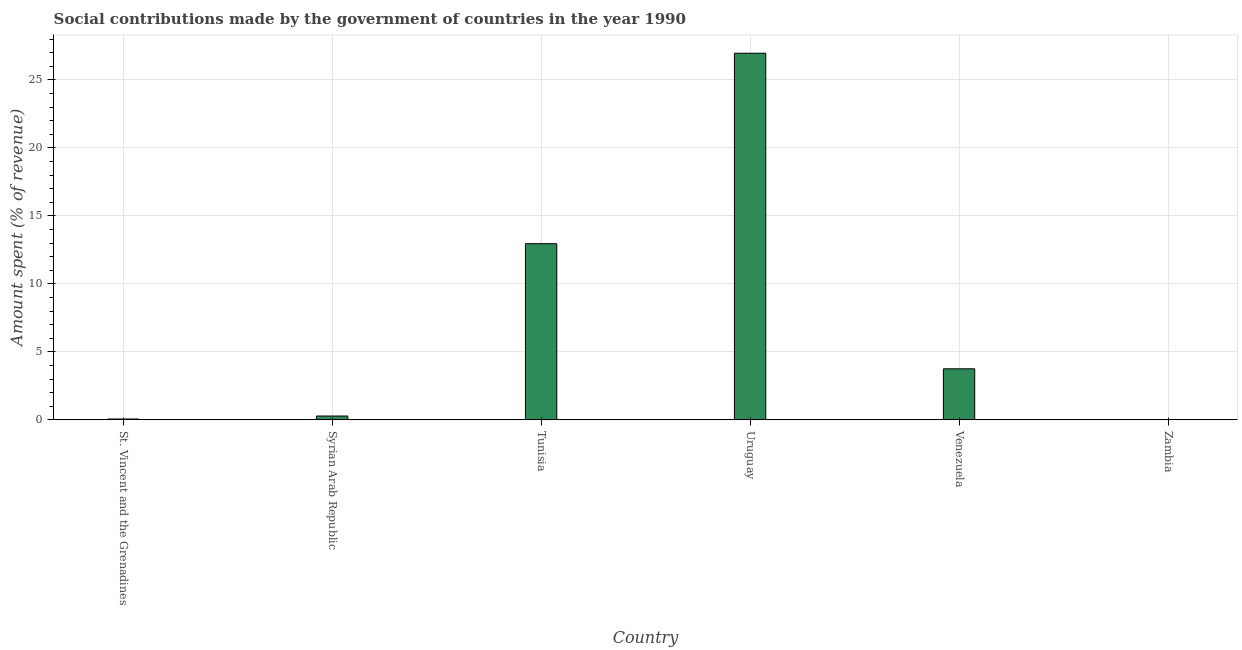What is the title of the graph?
Give a very brief answer. Social contributions made by the government of countries in the year 1990. What is the label or title of the Y-axis?
Your response must be concise. Amount spent (% of revenue). What is the amount spent in making social contributions in Syrian Arab Republic?
Give a very brief answer. 0.28. Across all countries, what is the maximum amount spent in making social contributions?
Give a very brief answer. 26.96. Across all countries, what is the minimum amount spent in making social contributions?
Give a very brief answer. 0. In which country was the amount spent in making social contributions maximum?
Your response must be concise. Uruguay. In which country was the amount spent in making social contributions minimum?
Provide a succinct answer. Zambia. What is the sum of the amount spent in making social contributions?
Offer a very short reply. 44. What is the difference between the amount spent in making social contributions in Tunisia and Venezuela?
Give a very brief answer. 9.2. What is the average amount spent in making social contributions per country?
Your response must be concise. 7.33. What is the median amount spent in making social contributions?
Provide a short and direct response. 2.01. In how many countries, is the amount spent in making social contributions greater than 20 %?
Give a very brief answer. 1. What is the ratio of the amount spent in making social contributions in Tunisia to that in Venezuela?
Your response must be concise. 3.45. What is the difference between the highest and the second highest amount spent in making social contributions?
Your answer should be very brief. 14.01. What is the difference between the highest and the lowest amount spent in making social contributions?
Offer a terse response. 26.95. In how many countries, is the amount spent in making social contributions greater than the average amount spent in making social contributions taken over all countries?
Ensure brevity in your answer.  2. What is the Amount spent (% of revenue) in St. Vincent and the Grenadines?
Make the answer very short. 0.06. What is the Amount spent (% of revenue) in Syrian Arab Republic?
Give a very brief answer. 0.28. What is the Amount spent (% of revenue) of Tunisia?
Your response must be concise. 12.95. What is the Amount spent (% of revenue) of Uruguay?
Give a very brief answer. 26.96. What is the Amount spent (% of revenue) of Venezuela?
Provide a short and direct response. 3.75. What is the Amount spent (% of revenue) in Zambia?
Your answer should be compact. 0. What is the difference between the Amount spent (% of revenue) in St. Vincent and the Grenadines and Syrian Arab Republic?
Offer a very short reply. -0.22. What is the difference between the Amount spent (% of revenue) in St. Vincent and the Grenadines and Tunisia?
Offer a terse response. -12.89. What is the difference between the Amount spent (% of revenue) in St. Vincent and the Grenadines and Uruguay?
Your answer should be compact. -26.9. What is the difference between the Amount spent (% of revenue) in St. Vincent and the Grenadines and Venezuela?
Your answer should be very brief. -3.69. What is the difference between the Amount spent (% of revenue) in St. Vincent and the Grenadines and Zambia?
Offer a terse response. 0.06. What is the difference between the Amount spent (% of revenue) in Syrian Arab Republic and Tunisia?
Offer a terse response. -12.67. What is the difference between the Amount spent (% of revenue) in Syrian Arab Republic and Uruguay?
Give a very brief answer. -26.68. What is the difference between the Amount spent (% of revenue) in Syrian Arab Republic and Venezuela?
Offer a terse response. -3.47. What is the difference between the Amount spent (% of revenue) in Syrian Arab Republic and Zambia?
Offer a very short reply. 0.27. What is the difference between the Amount spent (% of revenue) in Tunisia and Uruguay?
Your answer should be very brief. -14.01. What is the difference between the Amount spent (% of revenue) in Tunisia and Venezuela?
Make the answer very short. 9.2. What is the difference between the Amount spent (% of revenue) in Tunisia and Zambia?
Keep it short and to the point. 12.95. What is the difference between the Amount spent (% of revenue) in Uruguay and Venezuela?
Offer a very short reply. 23.21. What is the difference between the Amount spent (% of revenue) in Uruguay and Zambia?
Offer a very short reply. 26.95. What is the difference between the Amount spent (% of revenue) in Venezuela and Zambia?
Your response must be concise. 3.75. What is the ratio of the Amount spent (% of revenue) in St. Vincent and the Grenadines to that in Syrian Arab Republic?
Ensure brevity in your answer.  0.21. What is the ratio of the Amount spent (% of revenue) in St. Vincent and the Grenadines to that in Tunisia?
Give a very brief answer. 0.01. What is the ratio of the Amount spent (% of revenue) in St. Vincent and the Grenadines to that in Uruguay?
Give a very brief answer. 0. What is the ratio of the Amount spent (% of revenue) in St. Vincent and the Grenadines to that in Venezuela?
Your answer should be very brief. 0.02. What is the ratio of the Amount spent (% of revenue) in St. Vincent and the Grenadines to that in Zambia?
Offer a very short reply. 17.3. What is the ratio of the Amount spent (% of revenue) in Syrian Arab Republic to that in Tunisia?
Ensure brevity in your answer.  0.02. What is the ratio of the Amount spent (% of revenue) in Syrian Arab Republic to that in Uruguay?
Ensure brevity in your answer.  0.01. What is the ratio of the Amount spent (% of revenue) in Syrian Arab Republic to that in Venezuela?
Provide a short and direct response. 0.07. What is the ratio of the Amount spent (% of revenue) in Syrian Arab Republic to that in Zambia?
Make the answer very short. 81.41. What is the ratio of the Amount spent (% of revenue) in Tunisia to that in Uruguay?
Ensure brevity in your answer.  0.48. What is the ratio of the Amount spent (% of revenue) in Tunisia to that in Venezuela?
Give a very brief answer. 3.45. What is the ratio of the Amount spent (% of revenue) in Tunisia to that in Zambia?
Offer a very short reply. 3795.36. What is the ratio of the Amount spent (% of revenue) in Uruguay to that in Venezuela?
Offer a terse response. 7.19. What is the ratio of the Amount spent (% of revenue) in Uruguay to that in Zambia?
Make the answer very short. 7900.55. What is the ratio of the Amount spent (% of revenue) in Venezuela to that in Zambia?
Make the answer very short. 1098.98. 